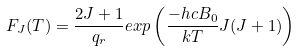Convert formula to latex. <formula><loc_0><loc_0><loc_500><loc_500>F _ { J } ( T ) = \frac { 2 J + 1 } { q _ { r } } e x p \left ( \frac { - h c B _ { 0 } } { k T } J ( J + 1 ) \right )</formula> 